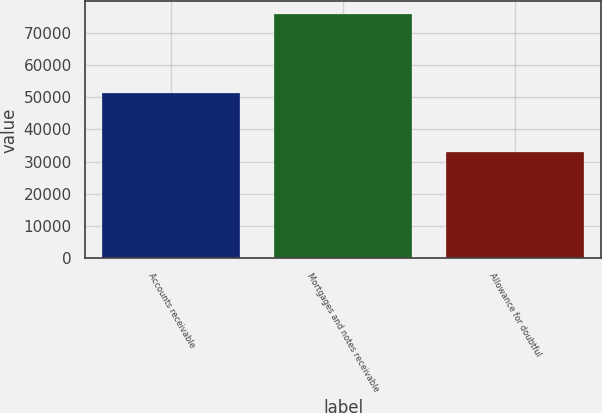Convert chart. <chart><loc_0><loc_0><loc_500><loc_500><bar_chart><fcel>Accounts receivable<fcel>Mortgages and notes receivable<fcel>Allowance for doubtful<nl><fcel>51491<fcel>76002<fcel>32973<nl></chart> 